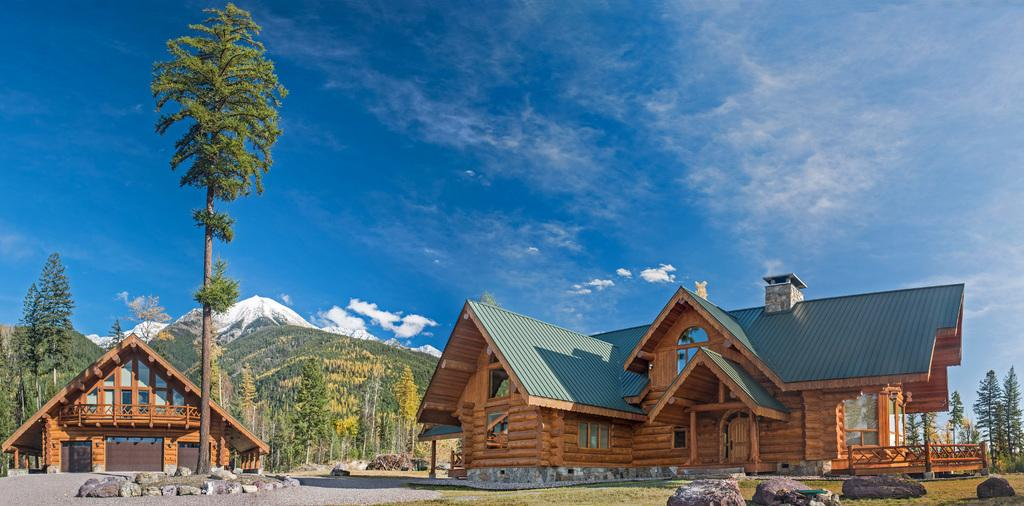What type of terrain is visible in the image? There is sand, grass, and stones visible in the image. What type of structures can be seen in the image? There are houses in the image. What can be seen in the background of the image? There are trees and mountains in the background of the image. What part of the natural environment is visible in the image? The sky is visible in the image. What type of impulse can be seen affecting the trees in the image? There is no impulse affecting the trees in the image; they are stationary. How does the trail lead to the mountains in the image? There is no trail present in the image; it only features sand, grass, stones, houses, trees, mountains, and the sky. 